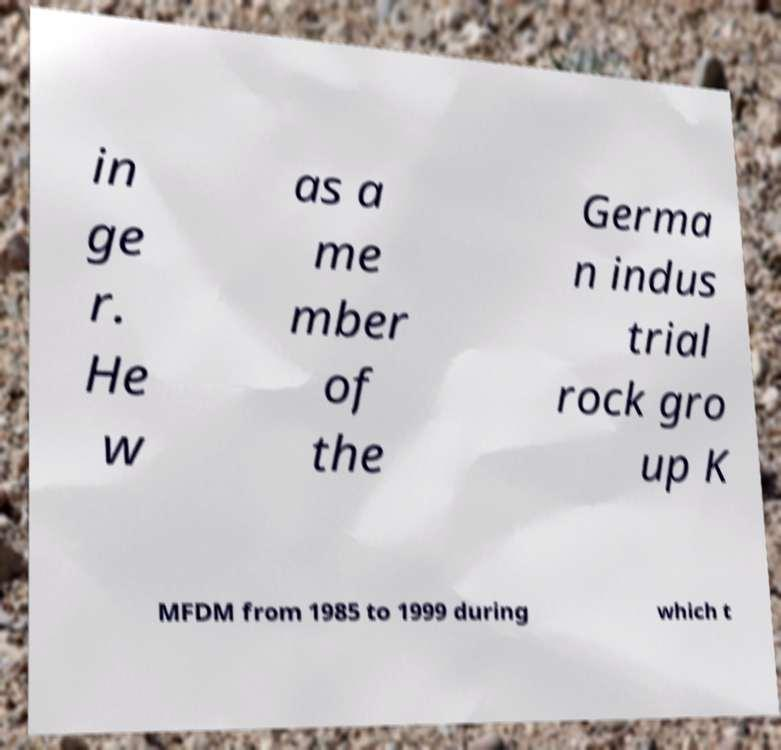Can you accurately transcribe the text from the provided image for me? in ge r. He w as a me mber of the Germa n indus trial rock gro up K MFDM from 1985 to 1999 during which t 